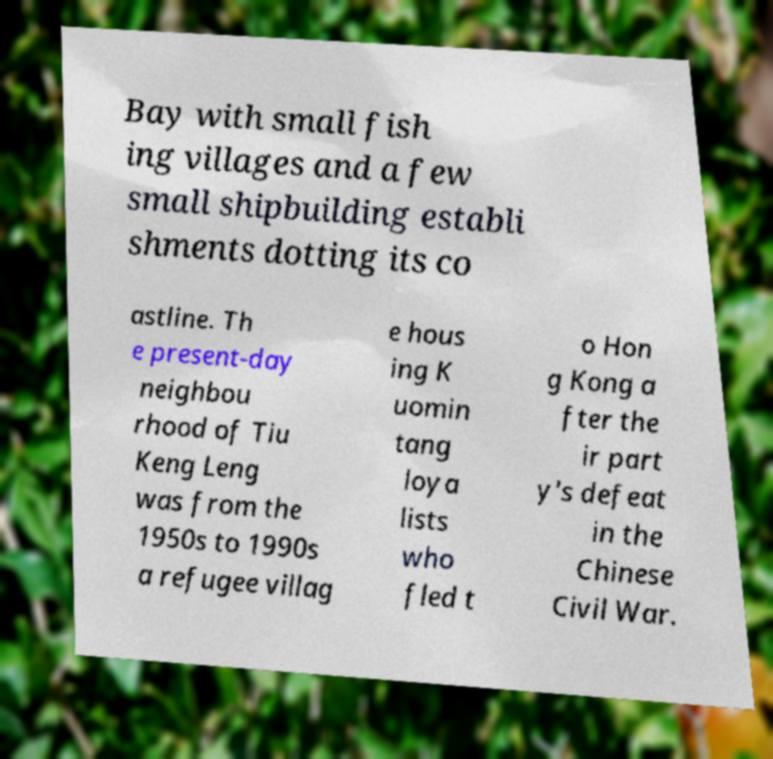For documentation purposes, I need the text within this image transcribed. Could you provide that? Bay with small fish ing villages and a few small shipbuilding establi shments dotting its co astline. Th e present-day neighbou rhood of Tiu Keng Leng was from the 1950s to 1990s a refugee villag e hous ing K uomin tang loya lists who fled t o Hon g Kong a fter the ir part y's defeat in the Chinese Civil War. 